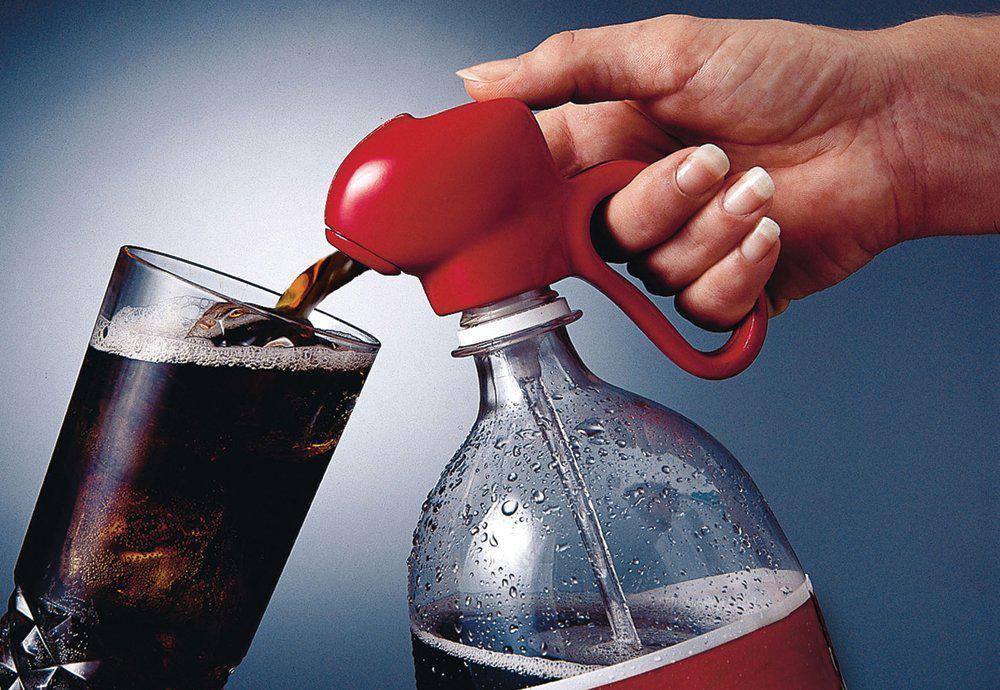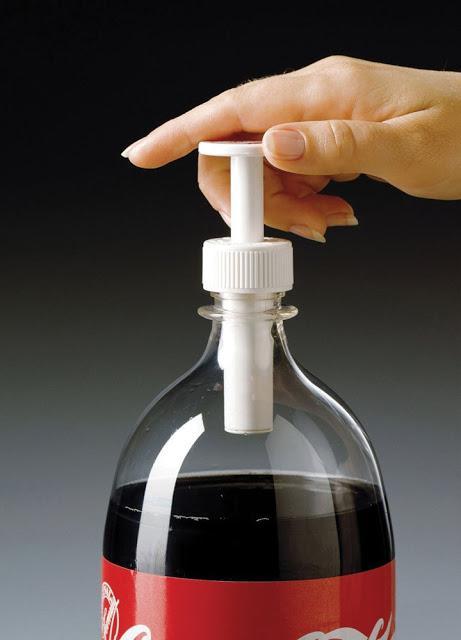The first image is the image on the left, the second image is the image on the right. Evaluate the accuracy of this statement regarding the images: "There are at least two hands.". Is it true? Answer yes or no. Yes. The first image is the image on the left, the second image is the image on the right. Examine the images to the left and right. Is the description "There is at least one  twisted  or crushed soda bottle" accurate? Answer yes or no. No. 